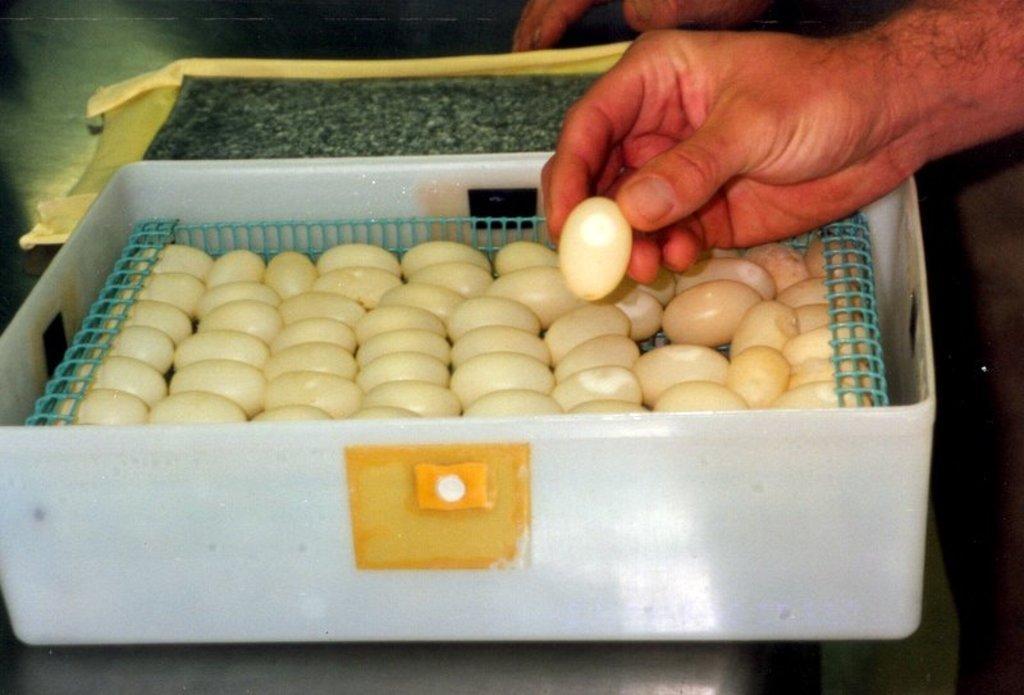Please provide a concise description of this image. At the bottom of the image we can see a table, on the table we can see a basket. In the basket we can see some eggs. In the top right corner of the image we can see a hand, in the hand we can see an egg. 